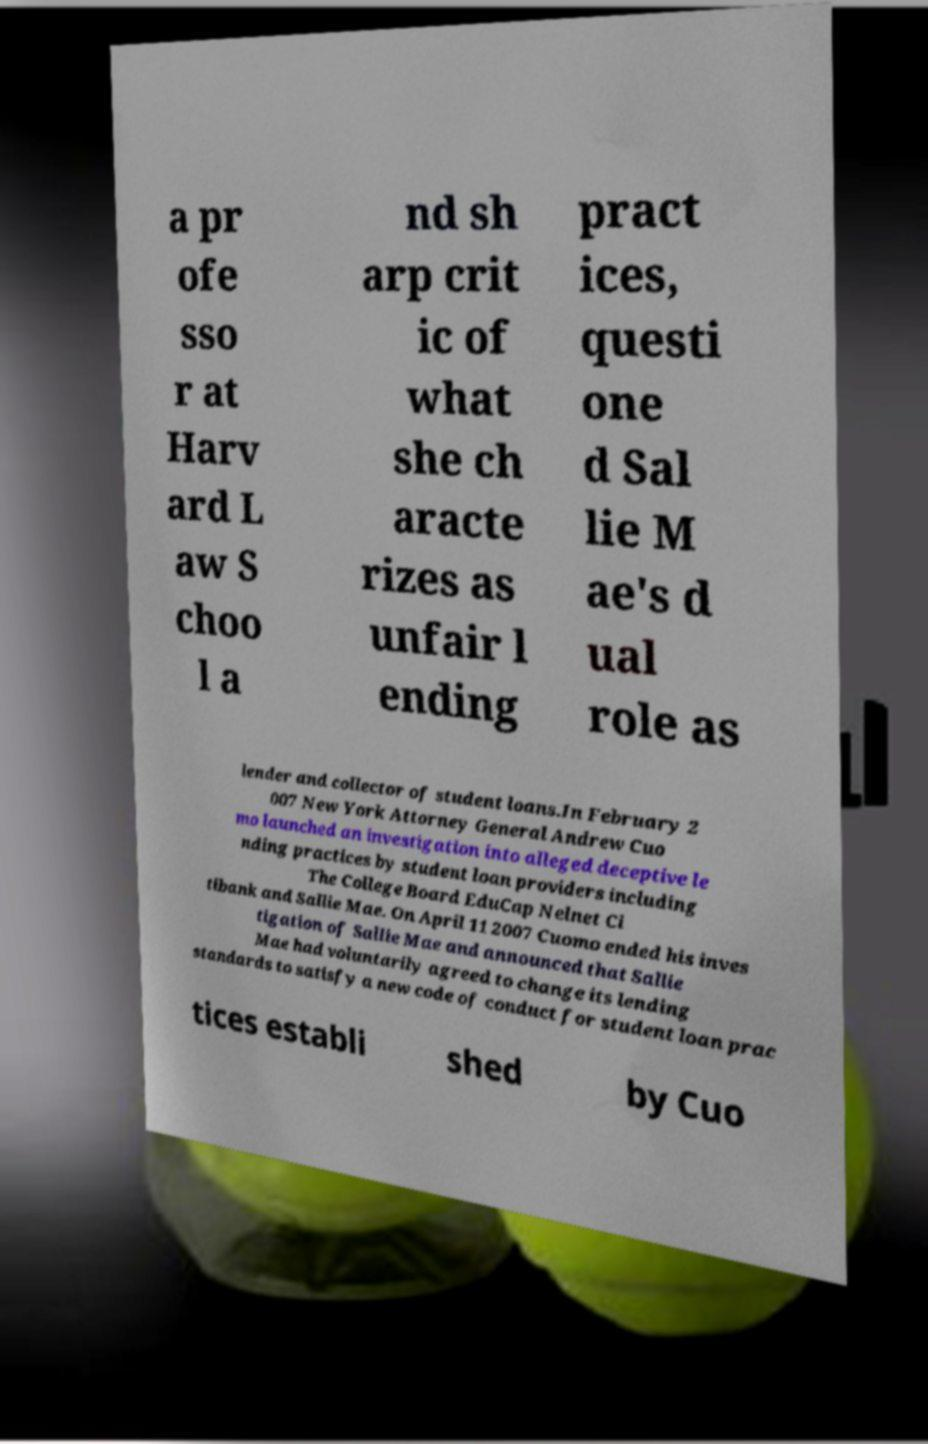I need the written content from this picture converted into text. Can you do that? a pr ofe sso r at Harv ard L aw S choo l a nd sh arp crit ic of what she ch aracte rizes as unfair l ending pract ices, questi one d Sal lie M ae's d ual role as lender and collector of student loans.In February 2 007 New York Attorney General Andrew Cuo mo launched an investigation into alleged deceptive le nding practices by student loan providers including The College Board EduCap Nelnet Ci tibank and Sallie Mae. On April 11 2007 Cuomo ended his inves tigation of Sallie Mae and announced that Sallie Mae had voluntarily agreed to change its lending standards to satisfy a new code of conduct for student loan prac tices establi shed by Cuo 